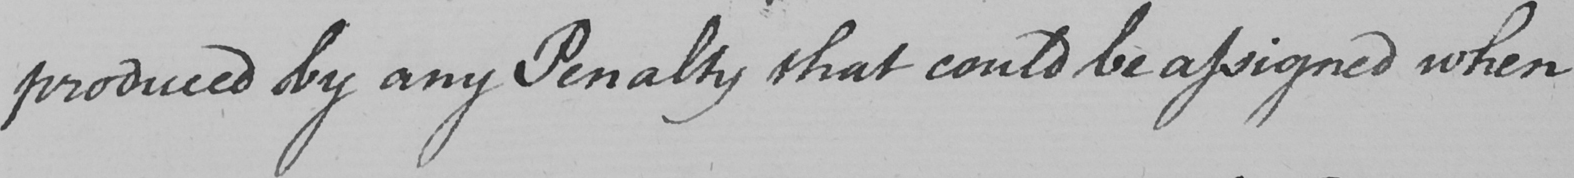Transcribe the text shown in this historical manuscript line. produced by any Penalty that could be assigned when 